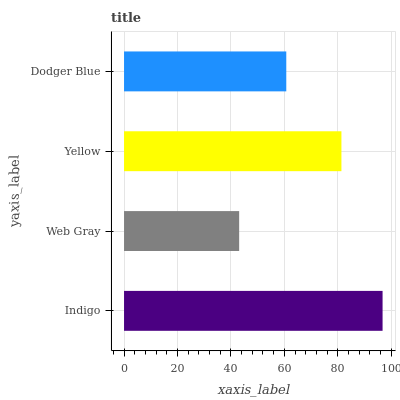Is Web Gray the minimum?
Answer yes or no. Yes. Is Indigo the maximum?
Answer yes or no. Yes. Is Yellow the minimum?
Answer yes or no. No. Is Yellow the maximum?
Answer yes or no. No. Is Yellow greater than Web Gray?
Answer yes or no. Yes. Is Web Gray less than Yellow?
Answer yes or no. Yes. Is Web Gray greater than Yellow?
Answer yes or no. No. Is Yellow less than Web Gray?
Answer yes or no. No. Is Yellow the high median?
Answer yes or no. Yes. Is Dodger Blue the low median?
Answer yes or no. Yes. Is Web Gray the high median?
Answer yes or no. No. Is Indigo the low median?
Answer yes or no. No. 